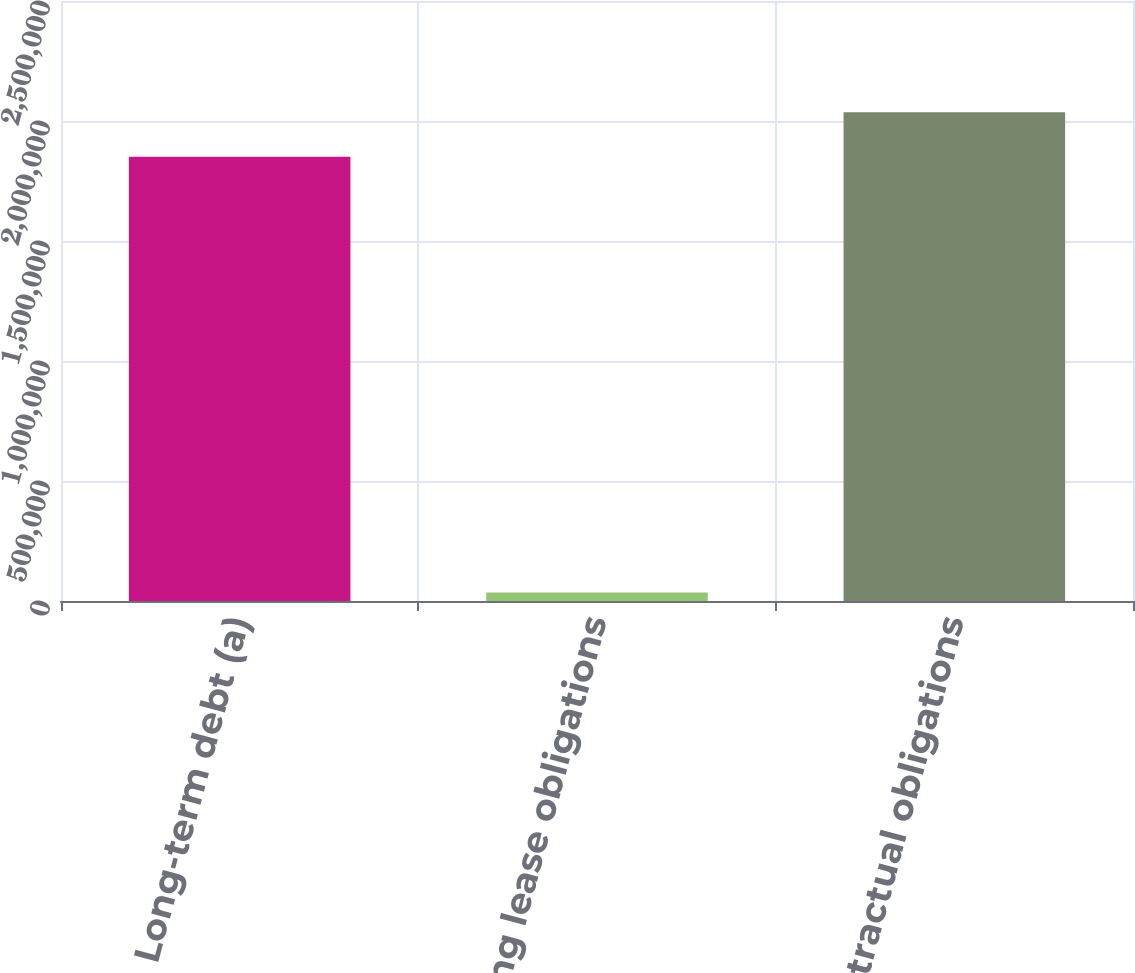<chart> <loc_0><loc_0><loc_500><loc_500><bar_chart><fcel>Long-term debt (a)<fcel>Operating lease obligations<fcel>Total contractual obligations<nl><fcel>1.85144e+06<fcel>34974<fcel>2.03658e+06<nl></chart> 